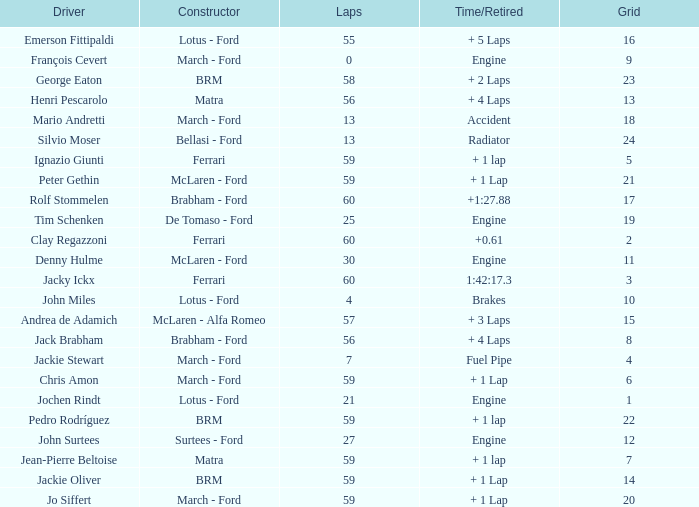I want the driver for grid of 9 François Cevert. Can you give me this table as a dict? {'header': ['Driver', 'Constructor', 'Laps', 'Time/Retired', 'Grid'], 'rows': [['Emerson Fittipaldi', 'Lotus - Ford', '55', '+ 5 Laps', '16'], ['François Cevert', 'March - Ford', '0', 'Engine', '9'], ['George Eaton', 'BRM', '58', '+ 2 Laps', '23'], ['Henri Pescarolo', 'Matra', '56', '+ 4 Laps', '13'], ['Mario Andretti', 'March - Ford', '13', 'Accident', '18'], ['Silvio Moser', 'Bellasi - Ford', '13', 'Radiator', '24'], ['Ignazio Giunti', 'Ferrari', '59', '+ 1 lap', '5'], ['Peter Gethin', 'McLaren - Ford', '59', '+ 1 Lap', '21'], ['Rolf Stommelen', 'Brabham - Ford', '60', '+1:27.88', '17'], ['Tim Schenken', 'De Tomaso - Ford', '25', 'Engine', '19'], ['Clay Regazzoni', 'Ferrari', '60', '+0.61', '2'], ['Denny Hulme', 'McLaren - Ford', '30', 'Engine', '11'], ['Jacky Ickx', 'Ferrari', '60', '1:42:17.3', '3'], ['John Miles', 'Lotus - Ford', '4', 'Brakes', '10'], ['Andrea de Adamich', 'McLaren - Alfa Romeo', '57', '+ 3 Laps', '15'], ['Jack Brabham', 'Brabham - Ford', '56', '+ 4 Laps', '8'], ['Jackie Stewart', 'March - Ford', '7', 'Fuel Pipe', '4'], ['Chris Amon', 'March - Ford', '59', '+ 1 Lap', '6'], ['Jochen Rindt', 'Lotus - Ford', '21', 'Engine', '1'], ['Pedro Rodríguez', 'BRM', '59', '+ 1 lap', '22'], ['John Surtees', 'Surtees - Ford', '27', 'Engine', '12'], ['Jean-Pierre Beltoise', 'Matra', '59', '+ 1 lap', '7'], ['Jackie Oliver', 'BRM', '59', '+ 1 Lap', '14'], ['Jo Siffert', 'March - Ford', '59', '+ 1 Lap', '20']]} 